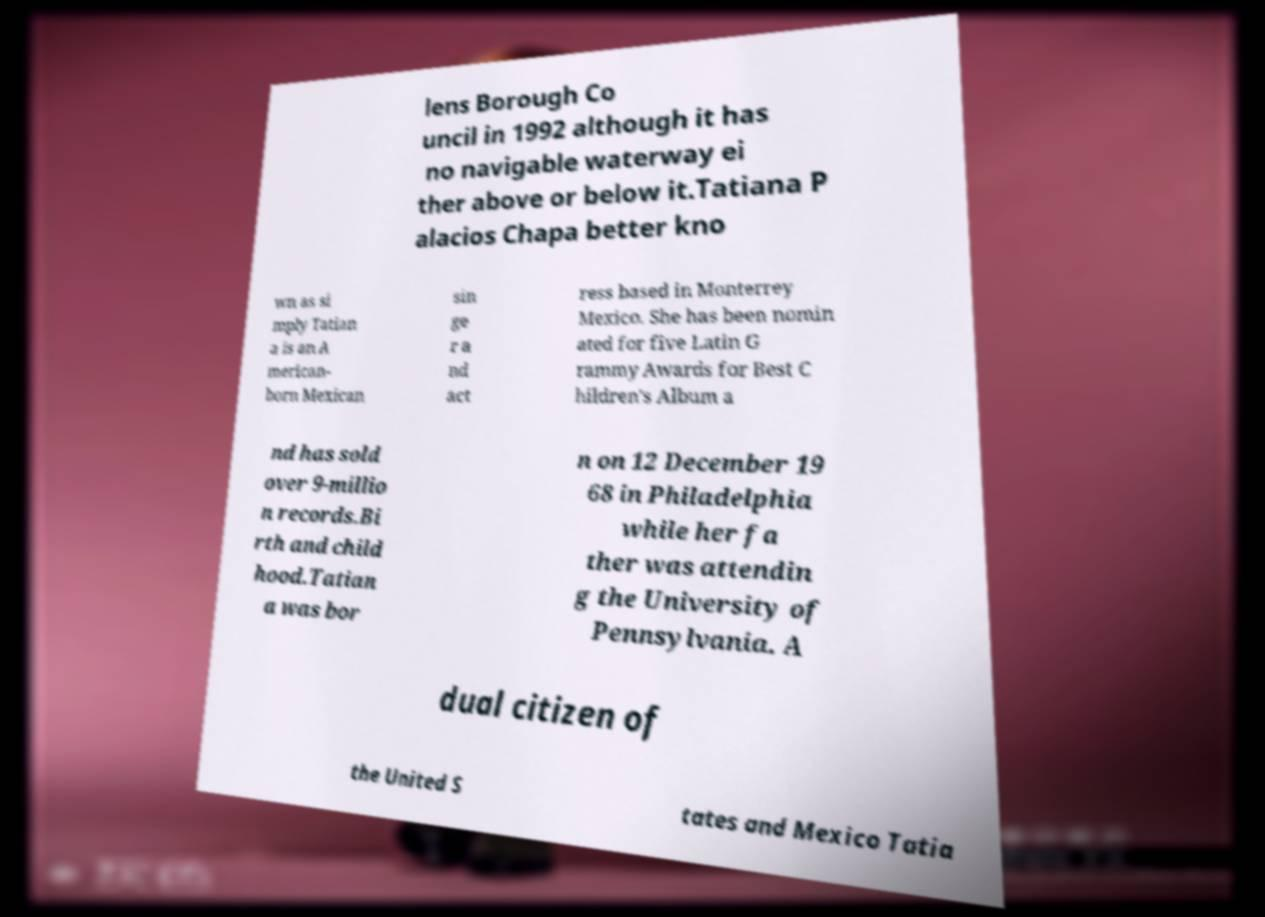Could you extract and type out the text from this image? lens Borough Co uncil in 1992 although it has no navigable waterway ei ther above or below it.Tatiana P alacios Chapa better kno wn as si mply Tatian a is an A merican- born Mexican sin ge r a nd act ress based in Monterrey Mexico. She has been nomin ated for five Latin G rammy Awards for Best C hildren's Album a nd has sold over 9-millio n records.Bi rth and child hood.Tatian a was bor n on 12 December 19 68 in Philadelphia while her fa ther was attendin g the University of Pennsylvania. A dual citizen of the United S tates and Mexico Tatia 